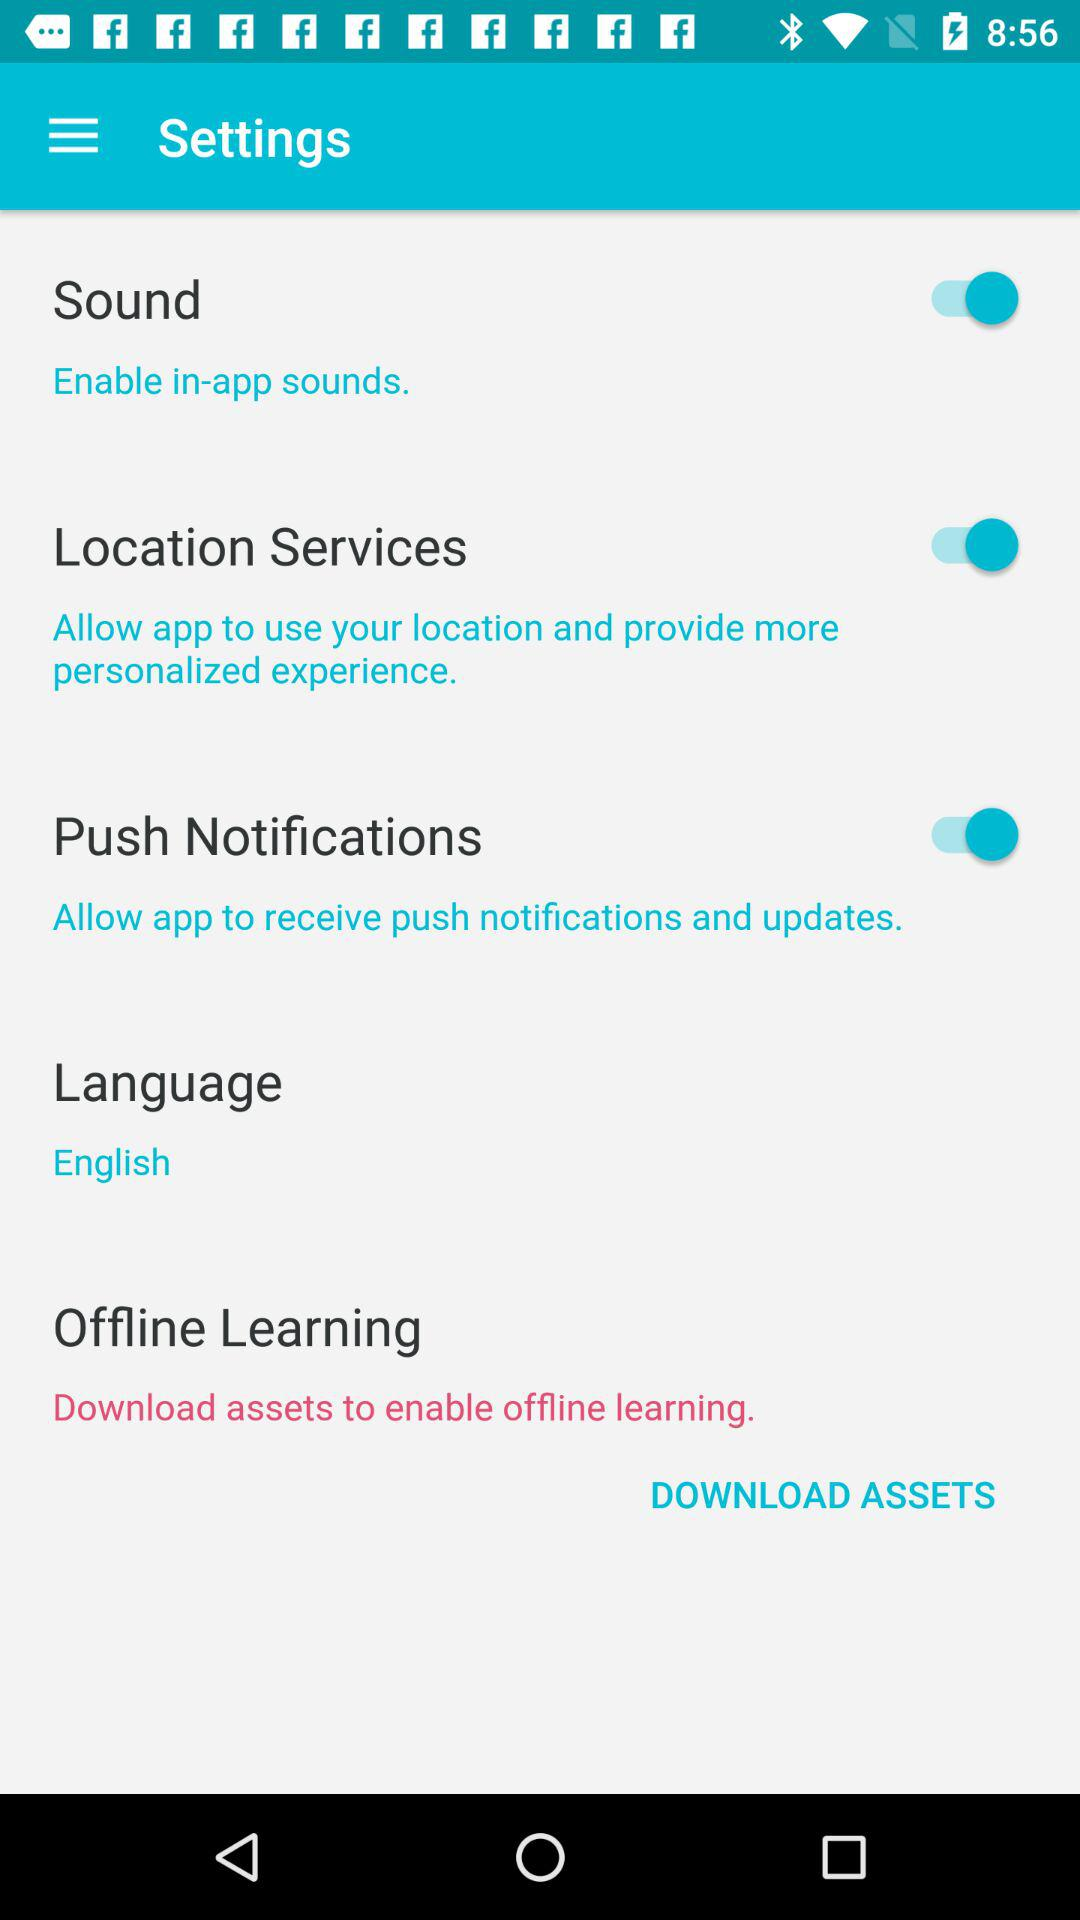What is the language? The language is English. 